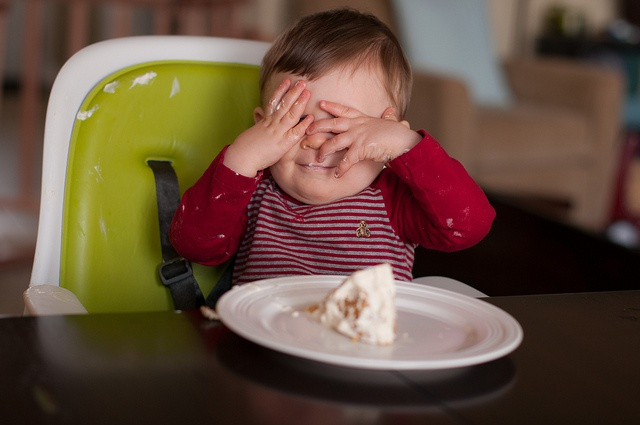Describe the objects in this image and their specific colors. I can see dining table in maroon, black, darkgray, and lightgray tones, people in maroon, salmon, black, and brown tones, chair in maroon, olive, lightgray, and darkgray tones, and cake in maroon, lightgray, and tan tones in this image. 